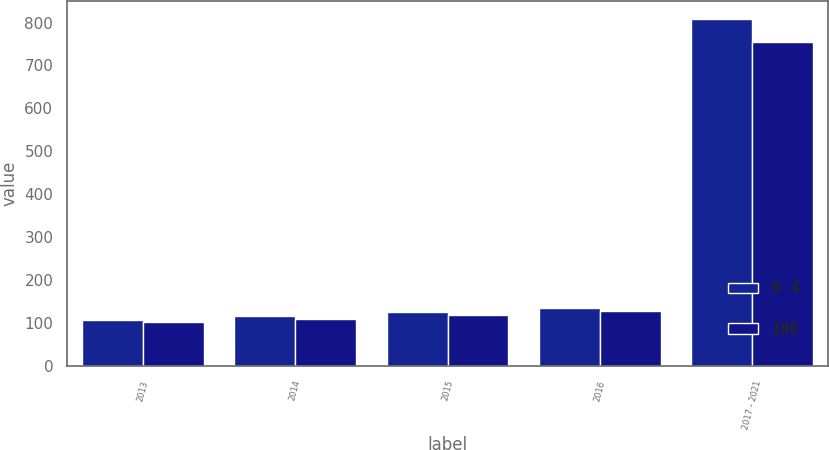Convert chart to OTSL. <chart><loc_0><loc_0><loc_500><loc_500><stacked_bar_chart><ecel><fcel>2013<fcel>2014<fcel>2015<fcel>2016<fcel>2017 - 2021<nl><fcel>9 4<fcel>108<fcel>117<fcel>126<fcel>136<fcel>809<nl><fcel>100<fcel>102<fcel>110<fcel>119<fcel>128<fcel>755<nl></chart> 